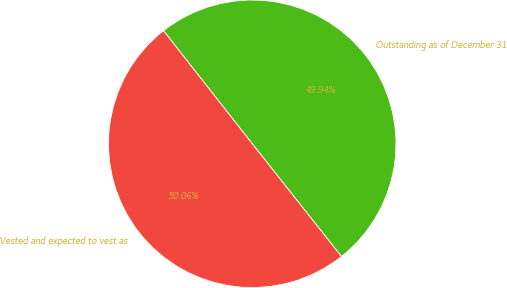<chart> <loc_0><loc_0><loc_500><loc_500><pie_chart><fcel>Outstanding as of December 31<fcel>Vested and expected to vest as<nl><fcel>49.94%<fcel>50.06%<nl></chart> 